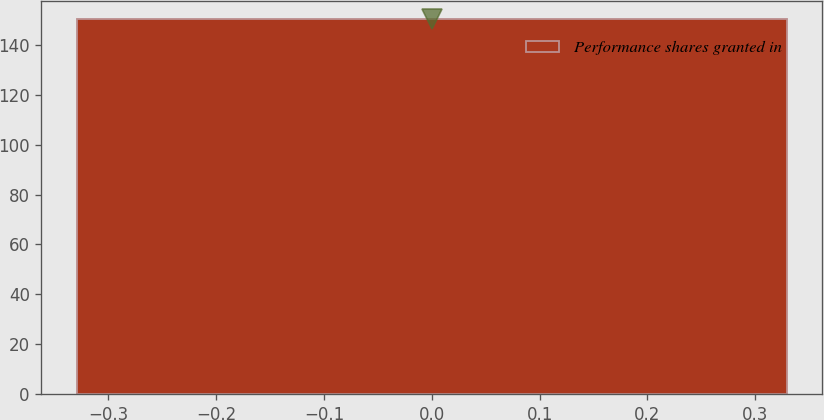<chart> <loc_0><loc_0><loc_500><loc_500><bar_chart><fcel>Performance shares granted in<nl><fcel>150.1<nl></chart> 